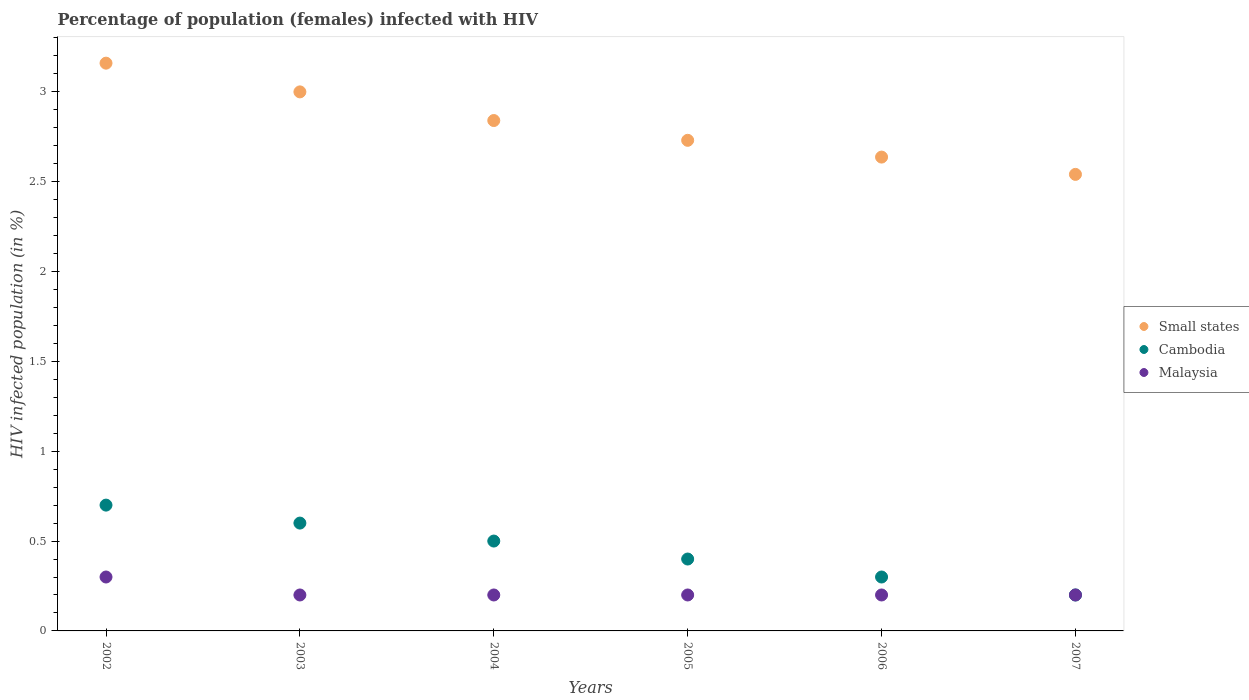How many different coloured dotlines are there?
Offer a terse response. 3. Is the number of dotlines equal to the number of legend labels?
Provide a short and direct response. Yes. Across all years, what is the maximum percentage of HIV infected female population in Cambodia?
Make the answer very short. 0.7. Across all years, what is the minimum percentage of HIV infected female population in Cambodia?
Provide a short and direct response. 0.2. What is the total percentage of HIV infected female population in Small states in the graph?
Provide a short and direct response. 16.9. What is the difference between the percentage of HIV infected female population in Cambodia in 2002 and that in 2006?
Give a very brief answer. 0.4. What is the difference between the percentage of HIV infected female population in Cambodia in 2002 and the percentage of HIV infected female population in Small states in 2003?
Offer a terse response. -2.3. What is the average percentage of HIV infected female population in Malaysia per year?
Offer a terse response. 0.22. In the year 2005, what is the difference between the percentage of HIV infected female population in Malaysia and percentage of HIV infected female population in Small states?
Offer a terse response. -2.53. What is the ratio of the percentage of HIV infected female population in Cambodia in 2004 to that in 2006?
Make the answer very short. 1.67. Is the difference between the percentage of HIV infected female population in Malaysia in 2005 and 2006 greater than the difference between the percentage of HIV infected female population in Small states in 2005 and 2006?
Offer a terse response. No. What is the difference between the highest and the second highest percentage of HIV infected female population in Small states?
Make the answer very short. 0.16. What is the difference between the highest and the lowest percentage of HIV infected female population in Cambodia?
Keep it short and to the point. 0.5. Is the sum of the percentage of HIV infected female population in Small states in 2002 and 2004 greater than the maximum percentage of HIV infected female population in Malaysia across all years?
Your answer should be compact. Yes. Is the percentage of HIV infected female population in Cambodia strictly greater than the percentage of HIV infected female population in Small states over the years?
Your answer should be compact. No. Is the percentage of HIV infected female population in Cambodia strictly less than the percentage of HIV infected female population in Small states over the years?
Provide a short and direct response. Yes. How many years are there in the graph?
Offer a very short reply. 6. What is the difference between two consecutive major ticks on the Y-axis?
Your answer should be very brief. 0.5. What is the title of the graph?
Your answer should be very brief. Percentage of population (females) infected with HIV. What is the label or title of the Y-axis?
Offer a terse response. HIV infected population (in %). What is the HIV infected population (in %) of Small states in 2002?
Your response must be concise. 3.16. What is the HIV infected population (in %) in Malaysia in 2002?
Offer a very short reply. 0.3. What is the HIV infected population (in %) in Small states in 2003?
Your answer should be very brief. 3. What is the HIV infected population (in %) of Small states in 2004?
Your answer should be very brief. 2.84. What is the HIV infected population (in %) of Cambodia in 2004?
Your answer should be compact. 0.5. What is the HIV infected population (in %) of Malaysia in 2004?
Your response must be concise. 0.2. What is the HIV infected population (in %) of Small states in 2005?
Your response must be concise. 2.73. What is the HIV infected population (in %) in Cambodia in 2005?
Your answer should be very brief. 0.4. What is the HIV infected population (in %) of Malaysia in 2005?
Keep it short and to the point. 0.2. What is the HIV infected population (in %) in Small states in 2006?
Give a very brief answer. 2.64. What is the HIV infected population (in %) in Small states in 2007?
Offer a terse response. 2.54. Across all years, what is the maximum HIV infected population (in %) of Small states?
Your answer should be compact. 3.16. Across all years, what is the maximum HIV infected population (in %) in Cambodia?
Your answer should be compact. 0.7. Across all years, what is the maximum HIV infected population (in %) in Malaysia?
Give a very brief answer. 0.3. Across all years, what is the minimum HIV infected population (in %) of Small states?
Keep it short and to the point. 2.54. What is the total HIV infected population (in %) of Small states in the graph?
Ensure brevity in your answer.  16.9. What is the total HIV infected population (in %) in Cambodia in the graph?
Your response must be concise. 2.7. What is the difference between the HIV infected population (in %) in Small states in 2002 and that in 2003?
Give a very brief answer. 0.16. What is the difference between the HIV infected population (in %) in Cambodia in 2002 and that in 2003?
Your answer should be very brief. 0.1. What is the difference between the HIV infected population (in %) of Malaysia in 2002 and that in 2003?
Ensure brevity in your answer.  0.1. What is the difference between the HIV infected population (in %) of Small states in 2002 and that in 2004?
Keep it short and to the point. 0.32. What is the difference between the HIV infected population (in %) of Small states in 2002 and that in 2005?
Your answer should be very brief. 0.43. What is the difference between the HIV infected population (in %) in Cambodia in 2002 and that in 2005?
Make the answer very short. 0.3. What is the difference between the HIV infected population (in %) of Small states in 2002 and that in 2006?
Ensure brevity in your answer.  0.52. What is the difference between the HIV infected population (in %) in Cambodia in 2002 and that in 2006?
Provide a short and direct response. 0.4. What is the difference between the HIV infected population (in %) of Malaysia in 2002 and that in 2006?
Keep it short and to the point. 0.1. What is the difference between the HIV infected population (in %) in Small states in 2002 and that in 2007?
Your answer should be very brief. 0.62. What is the difference between the HIV infected population (in %) in Malaysia in 2002 and that in 2007?
Make the answer very short. 0.1. What is the difference between the HIV infected population (in %) in Small states in 2003 and that in 2004?
Make the answer very short. 0.16. What is the difference between the HIV infected population (in %) of Cambodia in 2003 and that in 2004?
Provide a succinct answer. 0.1. What is the difference between the HIV infected population (in %) of Malaysia in 2003 and that in 2004?
Provide a short and direct response. 0. What is the difference between the HIV infected population (in %) of Small states in 2003 and that in 2005?
Offer a terse response. 0.27. What is the difference between the HIV infected population (in %) in Small states in 2003 and that in 2006?
Your answer should be compact. 0.36. What is the difference between the HIV infected population (in %) in Malaysia in 2003 and that in 2006?
Keep it short and to the point. 0. What is the difference between the HIV infected population (in %) of Small states in 2003 and that in 2007?
Offer a very short reply. 0.46. What is the difference between the HIV infected population (in %) of Malaysia in 2003 and that in 2007?
Keep it short and to the point. 0. What is the difference between the HIV infected population (in %) of Small states in 2004 and that in 2005?
Ensure brevity in your answer.  0.11. What is the difference between the HIV infected population (in %) in Small states in 2004 and that in 2006?
Provide a short and direct response. 0.2. What is the difference between the HIV infected population (in %) of Cambodia in 2004 and that in 2006?
Make the answer very short. 0.2. What is the difference between the HIV infected population (in %) in Malaysia in 2004 and that in 2006?
Offer a very short reply. 0. What is the difference between the HIV infected population (in %) in Small states in 2004 and that in 2007?
Keep it short and to the point. 0.3. What is the difference between the HIV infected population (in %) in Cambodia in 2004 and that in 2007?
Provide a short and direct response. 0.3. What is the difference between the HIV infected population (in %) of Malaysia in 2004 and that in 2007?
Your answer should be very brief. 0. What is the difference between the HIV infected population (in %) of Small states in 2005 and that in 2006?
Offer a terse response. 0.09. What is the difference between the HIV infected population (in %) in Small states in 2005 and that in 2007?
Make the answer very short. 0.19. What is the difference between the HIV infected population (in %) in Cambodia in 2005 and that in 2007?
Give a very brief answer. 0.2. What is the difference between the HIV infected population (in %) in Malaysia in 2005 and that in 2007?
Give a very brief answer. 0. What is the difference between the HIV infected population (in %) of Small states in 2006 and that in 2007?
Provide a short and direct response. 0.1. What is the difference between the HIV infected population (in %) in Malaysia in 2006 and that in 2007?
Provide a short and direct response. 0. What is the difference between the HIV infected population (in %) in Small states in 2002 and the HIV infected population (in %) in Cambodia in 2003?
Keep it short and to the point. 2.56. What is the difference between the HIV infected population (in %) in Small states in 2002 and the HIV infected population (in %) in Malaysia in 2003?
Your response must be concise. 2.96. What is the difference between the HIV infected population (in %) in Cambodia in 2002 and the HIV infected population (in %) in Malaysia in 2003?
Offer a very short reply. 0.5. What is the difference between the HIV infected population (in %) in Small states in 2002 and the HIV infected population (in %) in Cambodia in 2004?
Give a very brief answer. 2.66. What is the difference between the HIV infected population (in %) of Small states in 2002 and the HIV infected population (in %) of Malaysia in 2004?
Make the answer very short. 2.96. What is the difference between the HIV infected population (in %) in Cambodia in 2002 and the HIV infected population (in %) in Malaysia in 2004?
Your answer should be compact. 0.5. What is the difference between the HIV infected population (in %) of Small states in 2002 and the HIV infected population (in %) of Cambodia in 2005?
Offer a very short reply. 2.76. What is the difference between the HIV infected population (in %) in Small states in 2002 and the HIV infected population (in %) in Malaysia in 2005?
Provide a succinct answer. 2.96. What is the difference between the HIV infected population (in %) in Small states in 2002 and the HIV infected population (in %) in Cambodia in 2006?
Make the answer very short. 2.86. What is the difference between the HIV infected population (in %) of Small states in 2002 and the HIV infected population (in %) of Malaysia in 2006?
Your response must be concise. 2.96. What is the difference between the HIV infected population (in %) in Cambodia in 2002 and the HIV infected population (in %) in Malaysia in 2006?
Your response must be concise. 0.5. What is the difference between the HIV infected population (in %) of Small states in 2002 and the HIV infected population (in %) of Cambodia in 2007?
Your answer should be compact. 2.96. What is the difference between the HIV infected population (in %) of Small states in 2002 and the HIV infected population (in %) of Malaysia in 2007?
Offer a terse response. 2.96. What is the difference between the HIV infected population (in %) in Cambodia in 2002 and the HIV infected population (in %) in Malaysia in 2007?
Give a very brief answer. 0.5. What is the difference between the HIV infected population (in %) in Small states in 2003 and the HIV infected population (in %) in Cambodia in 2004?
Keep it short and to the point. 2.5. What is the difference between the HIV infected population (in %) in Small states in 2003 and the HIV infected population (in %) in Malaysia in 2004?
Ensure brevity in your answer.  2.8. What is the difference between the HIV infected population (in %) of Small states in 2003 and the HIV infected population (in %) of Cambodia in 2005?
Give a very brief answer. 2.6. What is the difference between the HIV infected population (in %) in Small states in 2003 and the HIV infected population (in %) in Malaysia in 2005?
Provide a short and direct response. 2.8. What is the difference between the HIV infected population (in %) in Cambodia in 2003 and the HIV infected population (in %) in Malaysia in 2005?
Make the answer very short. 0.4. What is the difference between the HIV infected population (in %) of Small states in 2003 and the HIV infected population (in %) of Cambodia in 2006?
Offer a terse response. 2.7. What is the difference between the HIV infected population (in %) of Small states in 2003 and the HIV infected population (in %) of Malaysia in 2006?
Offer a very short reply. 2.8. What is the difference between the HIV infected population (in %) in Small states in 2003 and the HIV infected population (in %) in Cambodia in 2007?
Keep it short and to the point. 2.8. What is the difference between the HIV infected population (in %) of Small states in 2003 and the HIV infected population (in %) of Malaysia in 2007?
Keep it short and to the point. 2.8. What is the difference between the HIV infected population (in %) of Cambodia in 2003 and the HIV infected population (in %) of Malaysia in 2007?
Keep it short and to the point. 0.4. What is the difference between the HIV infected population (in %) of Small states in 2004 and the HIV infected population (in %) of Cambodia in 2005?
Your answer should be very brief. 2.44. What is the difference between the HIV infected population (in %) of Small states in 2004 and the HIV infected population (in %) of Malaysia in 2005?
Give a very brief answer. 2.64. What is the difference between the HIV infected population (in %) in Cambodia in 2004 and the HIV infected population (in %) in Malaysia in 2005?
Provide a succinct answer. 0.3. What is the difference between the HIV infected population (in %) of Small states in 2004 and the HIV infected population (in %) of Cambodia in 2006?
Keep it short and to the point. 2.54. What is the difference between the HIV infected population (in %) of Small states in 2004 and the HIV infected population (in %) of Malaysia in 2006?
Give a very brief answer. 2.64. What is the difference between the HIV infected population (in %) in Small states in 2004 and the HIV infected population (in %) in Cambodia in 2007?
Offer a very short reply. 2.64. What is the difference between the HIV infected population (in %) of Small states in 2004 and the HIV infected population (in %) of Malaysia in 2007?
Your answer should be very brief. 2.64. What is the difference between the HIV infected population (in %) in Cambodia in 2004 and the HIV infected population (in %) in Malaysia in 2007?
Offer a very short reply. 0.3. What is the difference between the HIV infected population (in %) of Small states in 2005 and the HIV infected population (in %) of Cambodia in 2006?
Keep it short and to the point. 2.43. What is the difference between the HIV infected population (in %) of Small states in 2005 and the HIV infected population (in %) of Malaysia in 2006?
Make the answer very short. 2.53. What is the difference between the HIV infected population (in %) of Small states in 2005 and the HIV infected population (in %) of Cambodia in 2007?
Offer a very short reply. 2.53. What is the difference between the HIV infected population (in %) of Small states in 2005 and the HIV infected population (in %) of Malaysia in 2007?
Your answer should be very brief. 2.53. What is the difference between the HIV infected population (in %) in Small states in 2006 and the HIV infected population (in %) in Cambodia in 2007?
Your response must be concise. 2.44. What is the difference between the HIV infected population (in %) of Small states in 2006 and the HIV infected population (in %) of Malaysia in 2007?
Your response must be concise. 2.44. What is the difference between the HIV infected population (in %) in Cambodia in 2006 and the HIV infected population (in %) in Malaysia in 2007?
Your answer should be very brief. 0.1. What is the average HIV infected population (in %) of Small states per year?
Offer a very short reply. 2.82. What is the average HIV infected population (in %) in Cambodia per year?
Ensure brevity in your answer.  0.45. What is the average HIV infected population (in %) in Malaysia per year?
Your response must be concise. 0.22. In the year 2002, what is the difference between the HIV infected population (in %) of Small states and HIV infected population (in %) of Cambodia?
Offer a terse response. 2.46. In the year 2002, what is the difference between the HIV infected population (in %) of Small states and HIV infected population (in %) of Malaysia?
Offer a terse response. 2.86. In the year 2003, what is the difference between the HIV infected population (in %) of Small states and HIV infected population (in %) of Cambodia?
Provide a succinct answer. 2.4. In the year 2003, what is the difference between the HIV infected population (in %) in Small states and HIV infected population (in %) in Malaysia?
Provide a succinct answer. 2.8. In the year 2004, what is the difference between the HIV infected population (in %) in Small states and HIV infected population (in %) in Cambodia?
Keep it short and to the point. 2.34. In the year 2004, what is the difference between the HIV infected population (in %) of Small states and HIV infected population (in %) of Malaysia?
Make the answer very short. 2.64. In the year 2004, what is the difference between the HIV infected population (in %) of Cambodia and HIV infected population (in %) of Malaysia?
Provide a short and direct response. 0.3. In the year 2005, what is the difference between the HIV infected population (in %) of Small states and HIV infected population (in %) of Cambodia?
Make the answer very short. 2.33. In the year 2005, what is the difference between the HIV infected population (in %) in Small states and HIV infected population (in %) in Malaysia?
Offer a terse response. 2.53. In the year 2006, what is the difference between the HIV infected population (in %) of Small states and HIV infected population (in %) of Cambodia?
Provide a succinct answer. 2.34. In the year 2006, what is the difference between the HIV infected population (in %) of Small states and HIV infected population (in %) of Malaysia?
Your answer should be very brief. 2.44. In the year 2006, what is the difference between the HIV infected population (in %) of Cambodia and HIV infected population (in %) of Malaysia?
Provide a succinct answer. 0.1. In the year 2007, what is the difference between the HIV infected population (in %) in Small states and HIV infected population (in %) in Cambodia?
Offer a terse response. 2.34. In the year 2007, what is the difference between the HIV infected population (in %) of Small states and HIV infected population (in %) of Malaysia?
Make the answer very short. 2.34. In the year 2007, what is the difference between the HIV infected population (in %) of Cambodia and HIV infected population (in %) of Malaysia?
Make the answer very short. 0. What is the ratio of the HIV infected population (in %) in Small states in 2002 to that in 2003?
Make the answer very short. 1.05. What is the ratio of the HIV infected population (in %) in Small states in 2002 to that in 2004?
Ensure brevity in your answer.  1.11. What is the ratio of the HIV infected population (in %) in Cambodia in 2002 to that in 2004?
Give a very brief answer. 1.4. What is the ratio of the HIV infected population (in %) in Malaysia in 2002 to that in 2004?
Ensure brevity in your answer.  1.5. What is the ratio of the HIV infected population (in %) in Small states in 2002 to that in 2005?
Offer a terse response. 1.16. What is the ratio of the HIV infected population (in %) of Small states in 2002 to that in 2006?
Provide a short and direct response. 1.2. What is the ratio of the HIV infected population (in %) of Cambodia in 2002 to that in 2006?
Make the answer very short. 2.33. What is the ratio of the HIV infected population (in %) in Malaysia in 2002 to that in 2006?
Give a very brief answer. 1.5. What is the ratio of the HIV infected population (in %) of Small states in 2002 to that in 2007?
Offer a very short reply. 1.24. What is the ratio of the HIV infected population (in %) of Malaysia in 2002 to that in 2007?
Ensure brevity in your answer.  1.5. What is the ratio of the HIV infected population (in %) of Small states in 2003 to that in 2004?
Provide a succinct answer. 1.06. What is the ratio of the HIV infected population (in %) in Cambodia in 2003 to that in 2004?
Provide a succinct answer. 1.2. What is the ratio of the HIV infected population (in %) in Malaysia in 2003 to that in 2004?
Offer a terse response. 1. What is the ratio of the HIV infected population (in %) of Small states in 2003 to that in 2005?
Ensure brevity in your answer.  1.1. What is the ratio of the HIV infected population (in %) of Small states in 2003 to that in 2006?
Give a very brief answer. 1.14. What is the ratio of the HIV infected population (in %) in Cambodia in 2003 to that in 2006?
Offer a very short reply. 2. What is the ratio of the HIV infected population (in %) of Malaysia in 2003 to that in 2006?
Provide a succinct answer. 1. What is the ratio of the HIV infected population (in %) in Small states in 2003 to that in 2007?
Make the answer very short. 1.18. What is the ratio of the HIV infected population (in %) in Malaysia in 2003 to that in 2007?
Make the answer very short. 1. What is the ratio of the HIV infected population (in %) in Small states in 2004 to that in 2005?
Provide a short and direct response. 1.04. What is the ratio of the HIV infected population (in %) of Cambodia in 2004 to that in 2005?
Your response must be concise. 1.25. What is the ratio of the HIV infected population (in %) in Small states in 2004 to that in 2006?
Give a very brief answer. 1.08. What is the ratio of the HIV infected population (in %) of Cambodia in 2004 to that in 2006?
Your answer should be compact. 1.67. What is the ratio of the HIV infected population (in %) in Small states in 2004 to that in 2007?
Your answer should be compact. 1.12. What is the ratio of the HIV infected population (in %) in Small states in 2005 to that in 2006?
Provide a succinct answer. 1.04. What is the ratio of the HIV infected population (in %) of Cambodia in 2005 to that in 2006?
Provide a succinct answer. 1.33. What is the ratio of the HIV infected population (in %) of Malaysia in 2005 to that in 2006?
Ensure brevity in your answer.  1. What is the ratio of the HIV infected population (in %) in Small states in 2005 to that in 2007?
Provide a short and direct response. 1.07. What is the ratio of the HIV infected population (in %) in Cambodia in 2005 to that in 2007?
Your answer should be very brief. 2. What is the ratio of the HIV infected population (in %) of Small states in 2006 to that in 2007?
Your response must be concise. 1.04. What is the difference between the highest and the second highest HIV infected population (in %) of Small states?
Give a very brief answer. 0.16. What is the difference between the highest and the second highest HIV infected population (in %) of Cambodia?
Offer a terse response. 0.1. What is the difference between the highest and the lowest HIV infected population (in %) of Small states?
Provide a succinct answer. 0.62. What is the difference between the highest and the lowest HIV infected population (in %) in Cambodia?
Offer a terse response. 0.5. 